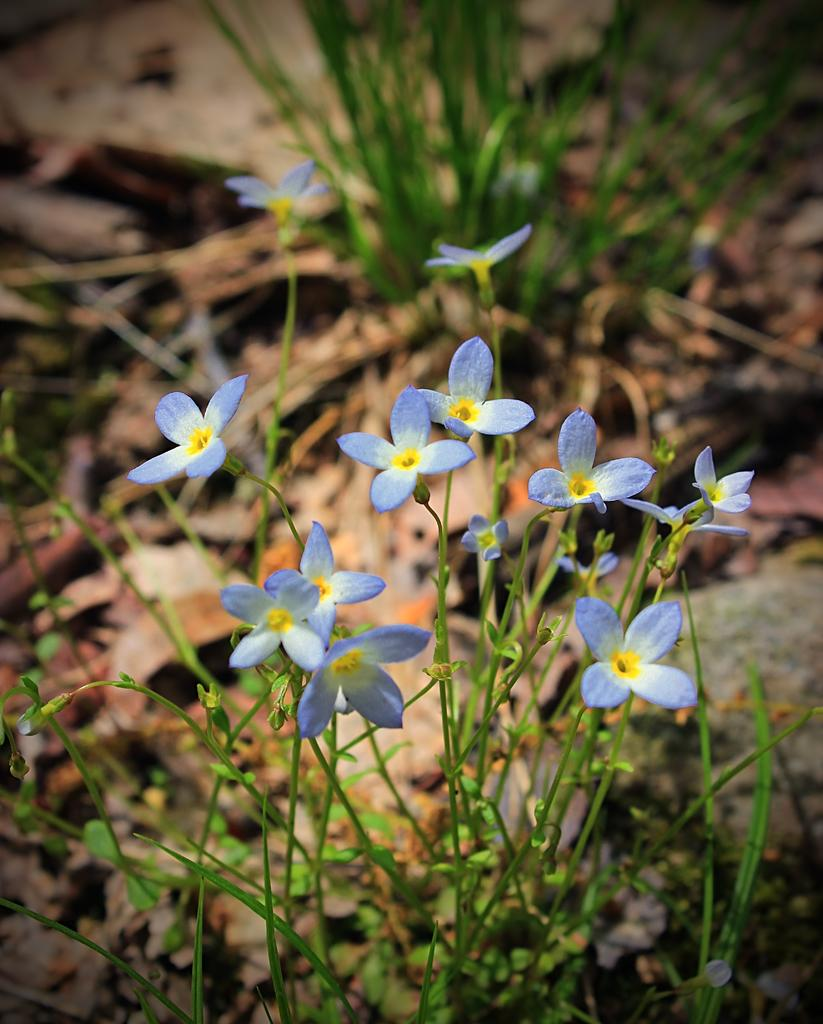What type of vegetation can be seen in the image? There are plants in the image, including grass on the ground and flowers with stems in the foreground. What is the texture of the ground in the image? The ground in the image is covered with grass. What can be seen in the foreground of the image? The foreground of the image features flowers with stems. How would you describe the background of the image? The background of the image is blurry. What type of rice is being harvested in the image? There is no rice present in the image; it features plants, grass, and flowers. What type of grain can be seen growing in the image? There is no grain present in the image; it features plants, grass, and flowers. 